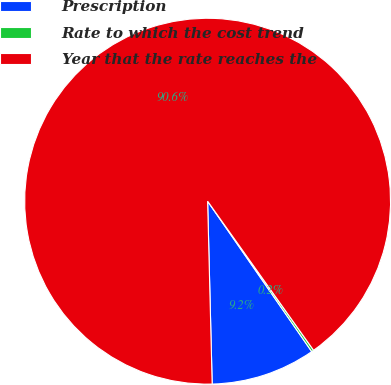Convert chart to OTSL. <chart><loc_0><loc_0><loc_500><loc_500><pie_chart><fcel>Prescription<fcel>Rate to which the cost trend<fcel>Year that the rate reaches the<nl><fcel>9.24%<fcel>0.2%<fcel>90.56%<nl></chart> 